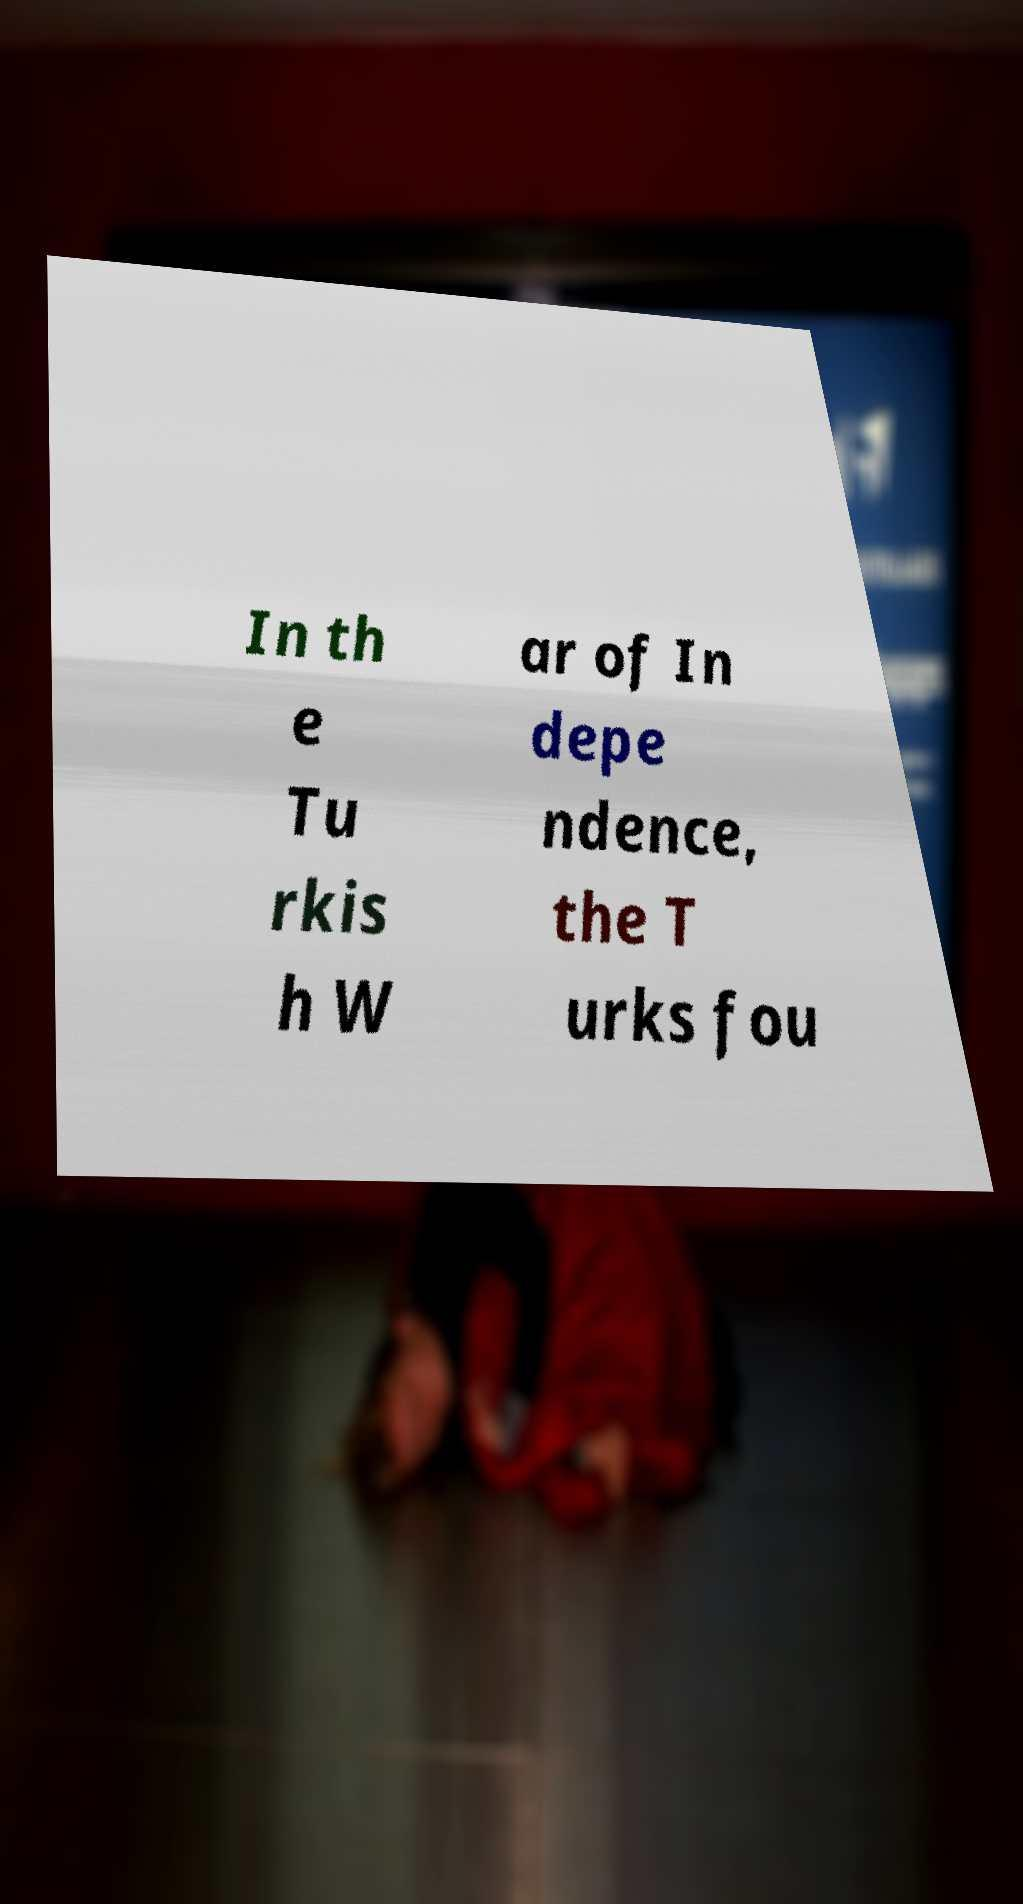Could you assist in decoding the text presented in this image and type it out clearly? In th e Tu rkis h W ar of In depe ndence, the T urks fou 